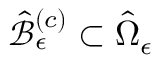Convert formula to latex. <formula><loc_0><loc_0><loc_500><loc_500>\hat { \mathcal { B } } _ { \epsilon } ^ { \left ( c \right ) } \subset \hat { \Omega } _ { \epsilon }</formula> 